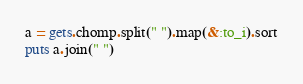<code> <loc_0><loc_0><loc_500><loc_500><_Ruby_>a = gets.chomp.split(" ").map(&:to_i).sort
puts a.join(" ")</code> 